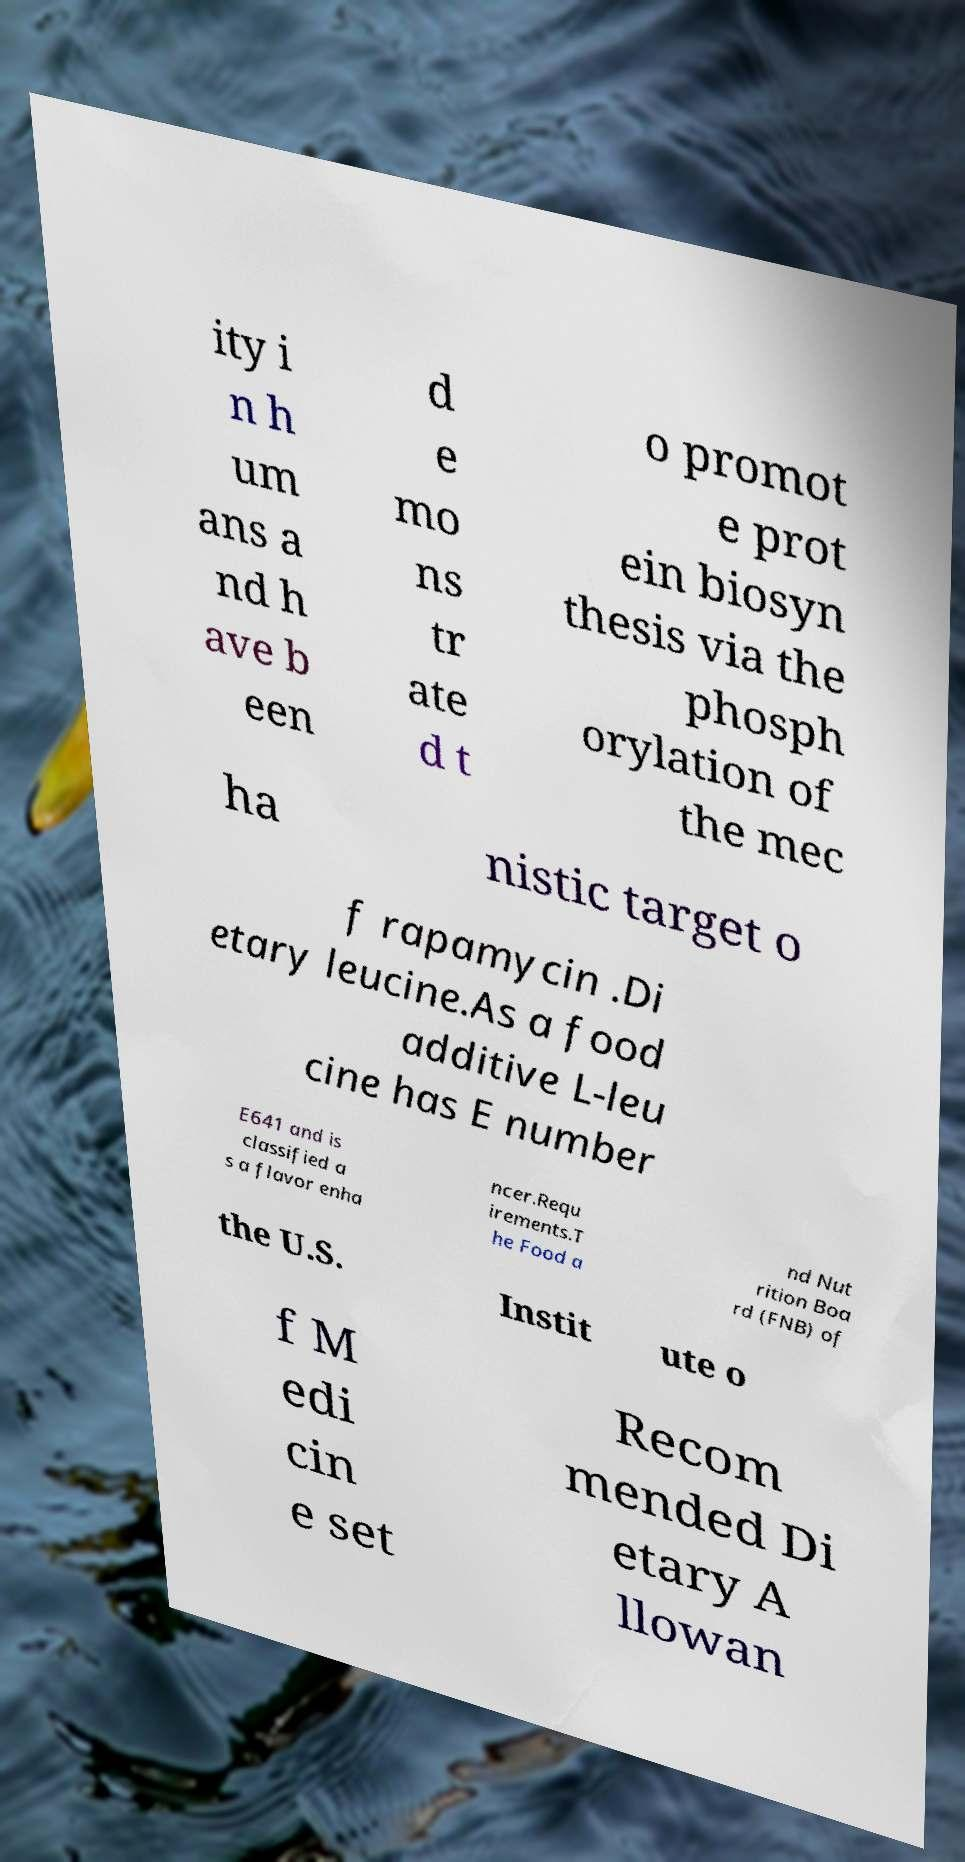Can you read and provide the text displayed in the image?This photo seems to have some interesting text. Can you extract and type it out for me? ity i n h um ans a nd h ave b een d e mo ns tr ate d t o promot e prot ein biosyn thesis via the phosph orylation of the mec ha nistic target o f rapamycin .Di etary leucine.As a food additive L-leu cine has E number E641 and is classified a s a flavor enha ncer.Requ irements.T he Food a nd Nut rition Boa rd (FNB) of the U.S. Instit ute o f M edi cin e set Recom mended Di etary A llowan 